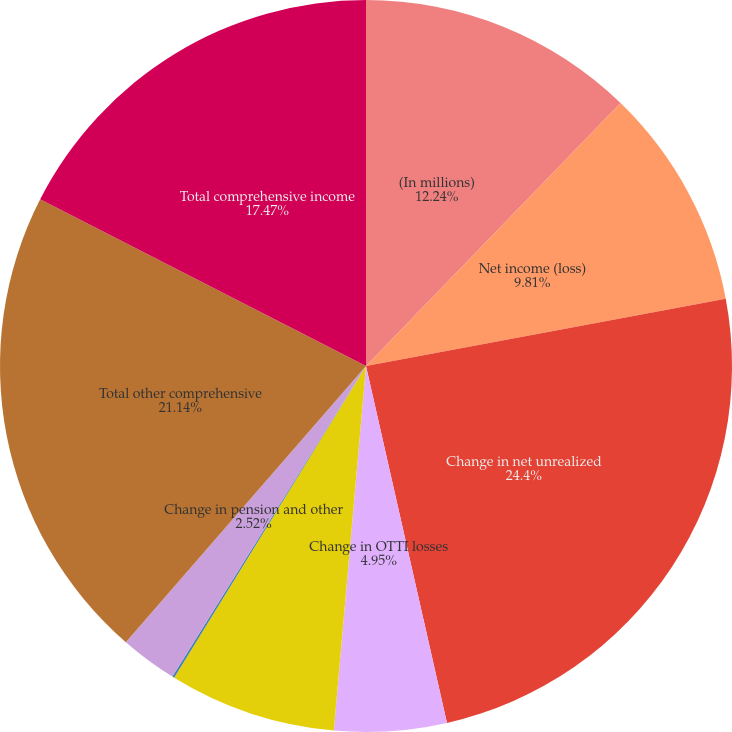<chart> <loc_0><loc_0><loc_500><loc_500><pie_chart><fcel>(In millions)<fcel>Net income (loss)<fcel>Change in net unrealized<fcel>Change in OTTI losses<fcel>Change in net gain/loss on<fcel>Change in foreign currency<fcel>Change in pension and other<fcel>Total other comprehensive<fcel>Total comprehensive income<nl><fcel>12.24%<fcel>9.81%<fcel>24.39%<fcel>4.95%<fcel>7.38%<fcel>0.09%<fcel>2.52%<fcel>21.13%<fcel>17.47%<nl></chart> 